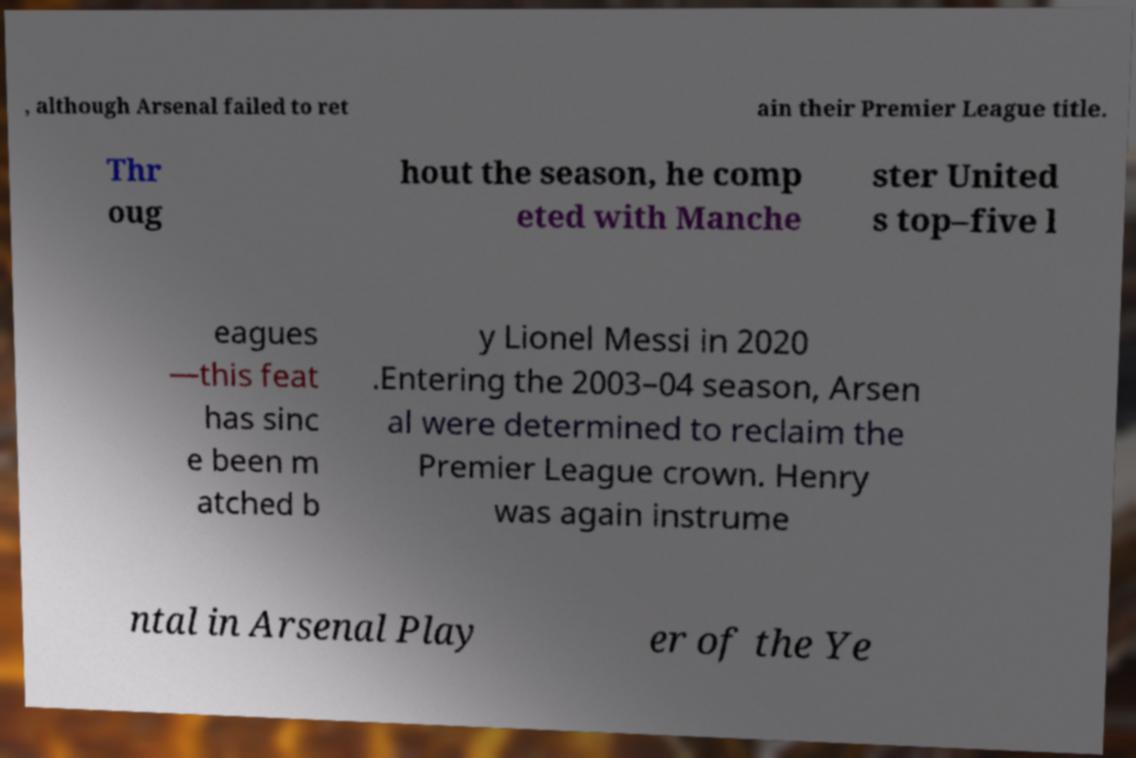Could you extract and type out the text from this image? , although Arsenal failed to ret ain their Premier League title. Thr oug hout the season, he comp eted with Manche ster United s top–five l eagues —this feat has sinc e been m atched b y Lionel Messi in 2020 .Entering the 2003–04 season, Arsen al were determined to reclaim the Premier League crown. Henry was again instrume ntal in Arsenal Play er of the Ye 